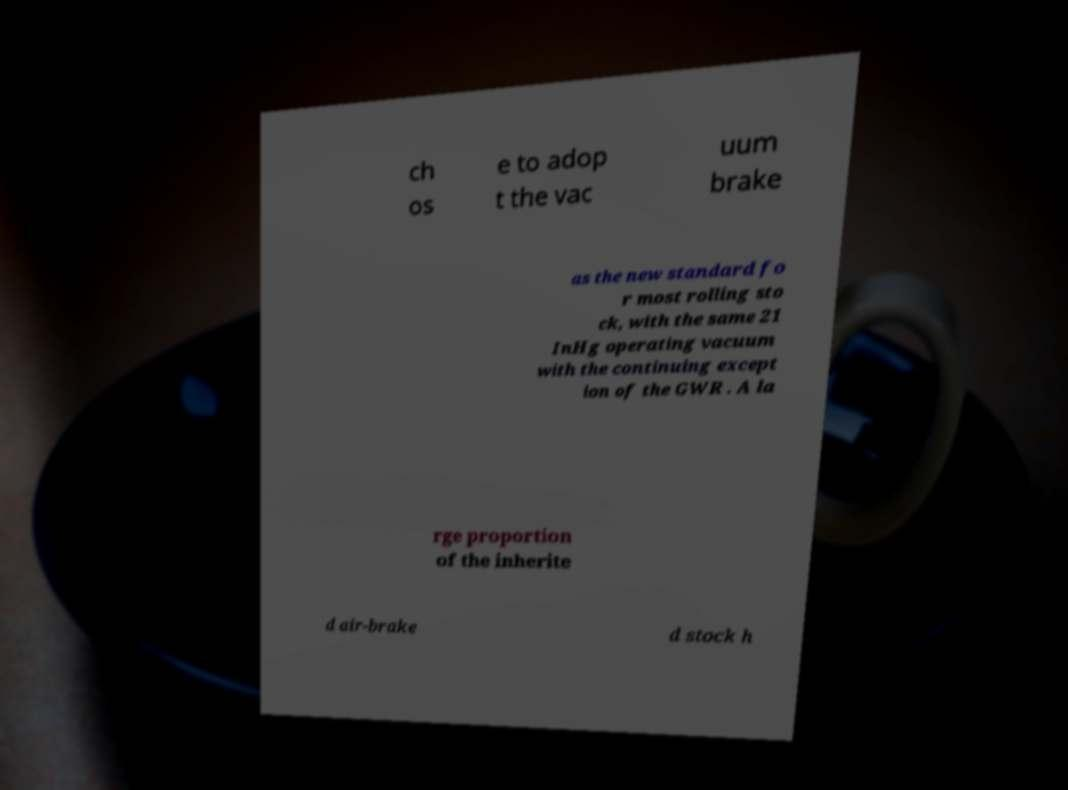What messages or text are displayed in this image? I need them in a readable, typed format. ch os e to adop t the vac uum brake as the new standard fo r most rolling sto ck, with the same 21 InHg operating vacuum with the continuing except ion of the GWR . A la rge proportion of the inherite d air-brake d stock h 